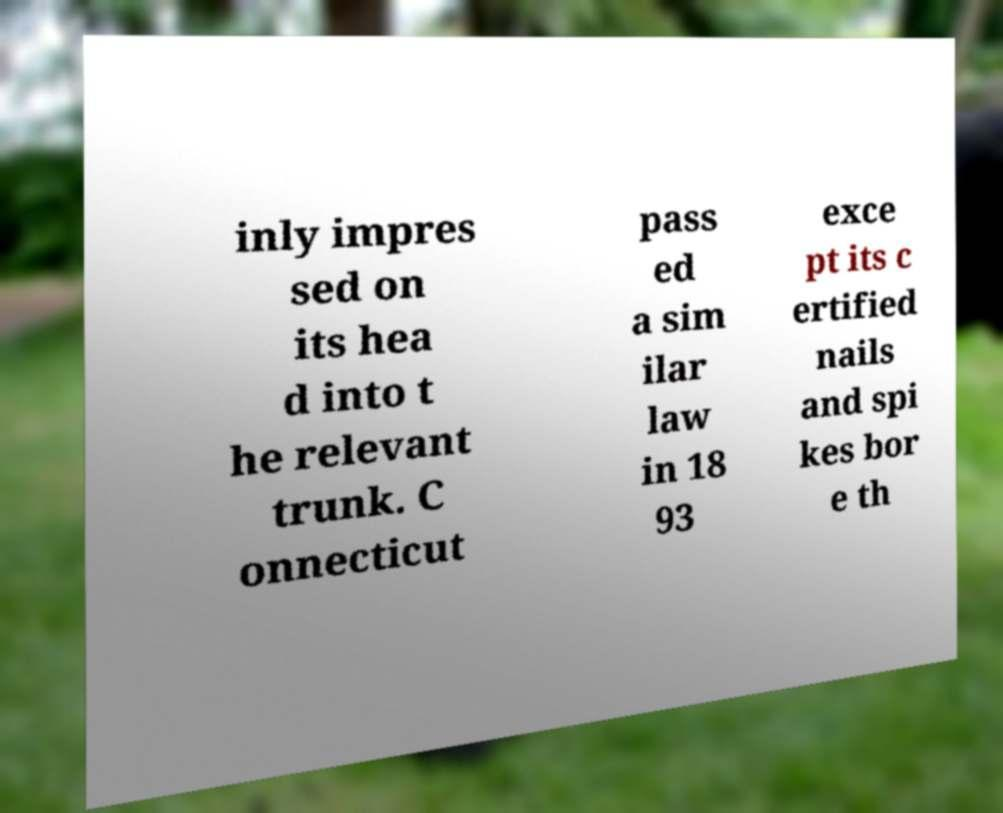Can you read and provide the text displayed in the image?This photo seems to have some interesting text. Can you extract and type it out for me? inly impres sed on its hea d into t he relevant trunk. C onnecticut pass ed a sim ilar law in 18 93 exce pt its c ertified nails and spi kes bor e th 